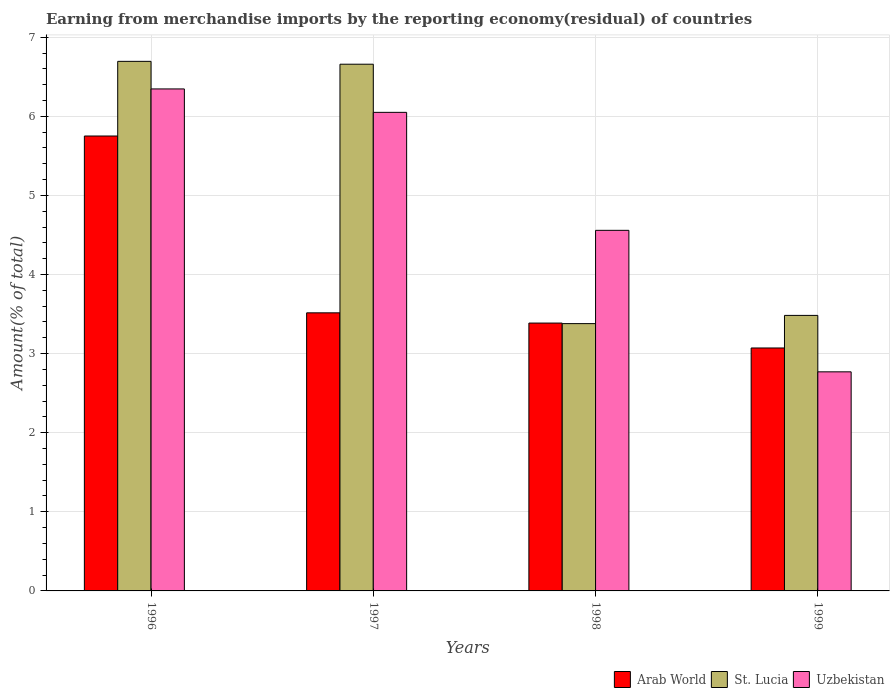How many different coloured bars are there?
Offer a terse response. 3. Are the number of bars per tick equal to the number of legend labels?
Your answer should be very brief. Yes. Are the number of bars on each tick of the X-axis equal?
Your answer should be compact. Yes. How many bars are there on the 3rd tick from the left?
Give a very brief answer. 3. How many bars are there on the 4th tick from the right?
Keep it short and to the point. 3. In how many cases, is the number of bars for a given year not equal to the number of legend labels?
Provide a short and direct response. 0. What is the percentage of amount earned from merchandise imports in St. Lucia in 1997?
Give a very brief answer. 6.66. Across all years, what is the maximum percentage of amount earned from merchandise imports in St. Lucia?
Your answer should be compact. 6.69. Across all years, what is the minimum percentage of amount earned from merchandise imports in St. Lucia?
Offer a terse response. 3.38. In which year was the percentage of amount earned from merchandise imports in Uzbekistan maximum?
Give a very brief answer. 1996. In which year was the percentage of amount earned from merchandise imports in Uzbekistan minimum?
Offer a very short reply. 1999. What is the total percentage of amount earned from merchandise imports in Arab World in the graph?
Your answer should be very brief. 15.72. What is the difference between the percentage of amount earned from merchandise imports in Arab World in 1997 and that in 1999?
Ensure brevity in your answer.  0.44. What is the difference between the percentage of amount earned from merchandise imports in Arab World in 1997 and the percentage of amount earned from merchandise imports in Uzbekistan in 1999?
Give a very brief answer. 0.75. What is the average percentage of amount earned from merchandise imports in Uzbekistan per year?
Provide a short and direct response. 4.93. In the year 1998, what is the difference between the percentage of amount earned from merchandise imports in St. Lucia and percentage of amount earned from merchandise imports in Uzbekistan?
Provide a short and direct response. -1.18. What is the ratio of the percentage of amount earned from merchandise imports in Uzbekistan in 1998 to that in 1999?
Make the answer very short. 1.65. Is the difference between the percentage of amount earned from merchandise imports in St. Lucia in 1998 and 1999 greater than the difference between the percentage of amount earned from merchandise imports in Uzbekistan in 1998 and 1999?
Provide a succinct answer. No. What is the difference between the highest and the second highest percentage of amount earned from merchandise imports in Uzbekistan?
Your response must be concise. 0.3. What is the difference between the highest and the lowest percentage of amount earned from merchandise imports in St. Lucia?
Give a very brief answer. 3.32. In how many years, is the percentage of amount earned from merchandise imports in St. Lucia greater than the average percentage of amount earned from merchandise imports in St. Lucia taken over all years?
Your answer should be very brief. 2. What does the 2nd bar from the left in 1996 represents?
Offer a terse response. St. Lucia. What does the 1st bar from the right in 1996 represents?
Keep it short and to the point. Uzbekistan. What is the difference between two consecutive major ticks on the Y-axis?
Make the answer very short. 1. Does the graph contain any zero values?
Give a very brief answer. No. How many legend labels are there?
Offer a very short reply. 3. How are the legend labels stacked?
Keep it short and to the point. Horizontal. What is the title of the graph?
Make the answer very short. Earning from merchandise imports by the reporting economy(residual) of countries. What is the label or title of the Y-axis?
Offer a terse response. Amount(% of total). What is the Amount(% of total) in Arab World in 1996?
Your answer should be compact. 5.75. What is the Amount(% of total) of St. Lucia in 1996?
Provide a succinct answer. 6.69. What is the Amount(% of total) in Uzbekistan in 1996?
Ensure brevity in your answer.  6.35. What is the Amount(% of total) of Arab World in 1997?
Keep it short and to the point. 3.52. What is the Amount(% of total) in St. Lucia in 1997?
Provide a short and direct response. 6.66. What is the Amount(% of total) of Uzbekistan in 1997?
Provide a short and direct response. 6.05. What is the Amount(% of total) in Arab World in 1998?
Provide a succinct answer. 3.39. What is the Amount(% of total) in St. Lucia in 1998?
Offer a very short reply. 3.38. What is the Amount(% of total) in Uzbekistan in 1998?
Give a very brief answer. 4.56. What is the Amount(% of total) in Arab World in 1999?
Keep it short and to the point. 3.07. What is the Amount(% of total) of St. Lucia in 1999?
Your answer should be very brief. 3.48. What is the Amount(% of total) in Uzbekistan in 1999?
Offer a terse response. 2.77. Across all years, what is the maximum Amount(% of total) of Arab World?
Your answer should be very brief. 5.75. Across all years, what is the maximum Amount(% of total) in St. Lucia?
Your response must be concise. 6.69. Across all years, what is the maximum Amount(% of total) in Uzbekistan?
Your answer should be compact. 6.35. Across all years, what is the minimum Amount(% of total) in Arab World?
Your answer should be very brief. 3.07. Across all years, what is the minimum Amount(% of total) in St. Lucia?
Your answer should be compact. 3.38. Across all years, what is the minimum Amount(% of total) in Uzbekistan?
Offer a terse response. 2.77. What is the total Amount(% of total) of Arab World in the graph?
Provide a succinct answer. 15.72. What is the total Amount(% of total) in St. Lucia in the graph?
Offer a very short reply. 20.21. What is the total Amount(% of total) of Uzbekistan in the graph?
Offer a terse response. 19.72. What is the difference between the Amount(% of total) in Arab World in 1996 and that in 1997?
Your answer should be compact. 2.24. What is the difference between the Amount(% of total) in St. Lucia in 1996 and that in 1997?
Give a very brief answer. 0.04. What is the difference between the Amount(% of total) in Uzbekistan in 1996 and that in 1997?
Your answer should be compact. 0.3. What is the difference between the Amount(% of total) in Arab World in 1996 and that in 1998?
Offer a terse response. 2.36. What is the difference between the Amount(% of total) of St. Lucia in 1996 and that in 1998?
Offer a terse response. 3.32. What is the difference between the Amount(% of total) in Uzbekistan in 1996 and that in 1998?
Provide a succinct answer. 1.79. What is the difference between the Amount(% of total) of Arab World in 1996 and that in 1999?
Your answer should be very brief. 2.68. What is the difference between the Amount(% of total) in St. Lucia in 1996 and that in 1999?
Offer a terse response. 3.21. What is the difference between the Amount(% of total) in Uzbekistan in 1996 and that in 1999?
Make the answer very short. 3.58. What is the difference between the Amount(% of total) in Arab World in 1997 and that in 1998?
Your response must be concise. 0.13. What is the difference between the Amount(% of total) in St. Lucia in 1997 and that in 1998?
Your answer should be very brief. 3.28. What is the difference between the Amount(% of total) of Uzbekistan in 1997 and that in 1998?
Offer a terse response. 1.49. What is the difference between the Amount(% of total) in Arab World in 1997 and that in 1999?
Give a very brief answer. 0.44. What is the difference between the Amount(% of total) of St. Lucia in 1997 and that in 1999?
Your answer should be compact. 3.18. What is the difference between the Amount(% of total) in Uzbekistan in 1997 and that in 1999?
Provide a succinct answer. 3.28. What is the difference between the Amount(% of total) of Arab World in 1998 and that in 1999?
Keep it short and to the point. 0.32. What is the difference between the Amount(% of total) in St. Lucia in 1998 and that in 1999?
Offer a terse response. -0.1. What is the difference between the Amount(% of total) in Uzbekistan in 1998 and that in 1999?
Keep it short and to the point. 1.79. What is the difference between the Amount(% of total) in Arab World in 1996 and the Amount(% of total) in St. Lucia in 1997?
Your answer should be compact. -0.91. What is the difference between the Amount(% of total) in Arab World in 1996 and the Amount(% of total) in Uzbekistan in 1997?
Offer a terse response. -0.3. What is the difference between the Amount(% of total) of St. Lucia in 1996 and the Amount(% of total) of Uzbekistan in 1997?
Your answer should be very brief. 0.64. What is the difference between the Amount(% of total) in Arab World in 1996 and the Amount(% of total) in St. Lucia in 1998?
Your response must be concise. 2.37. What is the difference between the Amount(% of total) in Arab World in 1996 and the Amount(% of total) in Uzbekistan in 1998?
Offer a very short reply. 1.19. What is the difference between the Amount(% of total) of St. Lucia in 1996 and the Amount(% of total) of Uzbekistan in 1998?
Make the answer very short. 2.14. What is the difference between the Amount(% of total) of Arab World in 1996 and the Amount(% of total) of St. Lucia in 1999?
Keep it short and to the point. 2.27. What is the difference between the Amount(% of total) in Arab World in 1996 and the Amount(% of total) in Uzbekistan in 1999?
Ensure brevity in your answer.  2.98. What is the difference between the Amount(% of total) of St. Lucia in 1996 and the Amount(% of total) of Uzbekistan in 1999?
Keep it short and to the point. 3.92. What is the difference between the Amount(% of total) in Arab World in 1997 and the Amount(% of total) in St. Lucia in 1998?
Ensure brevity in your answer.  0.14. What is the difference between the Amount(% of total) of Arab World in 1997 and the Amount(% of total) of Uzbekistan in 1998?
Your answer should be very brief. -1.04. What is the difference between the Amount(% of total) of Arab World in 1997 and the Amount(% of total) of St. Lucia in 1999?
Ensure brevity in your answer.  0.03. What is the difference between the Amount(% of total) in Arab World in 1997 and the Amount(% of total) in Uzbekistan in 1999?
Offer a terse response. 0.75. What is the difference between the Amount(% of total) of St. Lucia in 1997 and the Amount(% of total) of Uzbekistan in 1999?
Provide a short and direct response. 3.89. What is the difference between the Amount(% of total) in Arab World in 1998 and the Amount(% of total) in St. Lucia in 1999?
Offer a terse response. -0.1. What is the difference between the Amount(% of total) in Arab World in 1998 and the Amount(% of total) in Uzbekistan in 1999?
Offer a very short reply. 0.62. What is the difference between the Amount(% of total) in St. Lucia in 1998 and the Amount(% of total) in Uzbekistan in 1999?
Keep it short and to the point. 0.61. What is the average Amount(% of total) in Arab World per year?
Provide a succinct answer. 3.93. What is the average Amount(% of total) in St. Lucia per year?
Your answer should be compact. 5.05. What is the average Amount(% of total) in Uzbekistan per year?
Ensure brevity in your answer.  4.93. In the year 1996, what is the difference between the Amount(% of total) in Arab World and Amount(% of total) in St. Lucia?
Ensure brevity in your answer.  -0.94. In the year 1996, what is the difference between the Amount(% of total) in Arab World and Amount(% of total) in Uzbekistan?
Give a very brief answer. -0.6. In the year 1996, what is the difference between the Amount(% of total) in St. Lucia and Amount(% of total) in Uzbekistan?
Keep it short and to the point. 0.35. In the year 1997, what is the difference between the Amount(% of total) of Arab World and Amount(% of total) of St. Lucia?
Offer a very short reply. -3.14. In the year 1997, what is the difference between the Amount(% of total) in Arab World and Amount(% of total) in Uzbekistan?
Provide a succinct answer. -2.53. In the year 1997, what is the difference between the Amount(% of total) in St. Lucia and Amount(% of total) in Uzbekistan?
Give a very brief answer. 0.61. In the year 1998, what is the difference between the Amount(% of total) of Arab World and Amount(% of total) of St. Lucia?
Your answer should be very brief. 0.01. In the year 1998, what is the difference between the Amount(% of total) of Arab World and Amount(% of total) of Uzbekistan?
Keep it short and to the point. -1.17. In the year 1998, what is the difference between the Amount(% of total) of St. Lucia and Amount(% of total) of Uzbekistan?
Your response must be concise. -1.18. In the year 1999, what is the difference between the Amount(% of total) of Arab World and Amount(% of total) of St. Lucia?
Your answer should be compact. -0.41. In the year 1999, what is the difference between the Amount(% of total) of Arab World and Amount(% of total) of Uzbekistan?
Your response must be concise. 0.3. In the year 1999, what is the difference between the Amount(% of total) in St. Lucia and Amount(% of total) in Uzbekistan?
Make the answer very short. 0.71. What is the ratio of the Amount(% of total) of Arab World in 1996 to that in 1997?
Ensure brevity in your answer.  1.64. What is the ratio of the Amount(% of total) in St. Lucia in 1996 to that in 1997?
Your answer should be very brief. 1.01. What is the ratio of the Amount(% of total) of Uzbekistan in 1996 to that in 1997?
Offer a terse response. 1.05. What is the ratio of the Amount(% of total) in Arab World in 1996 to that in 1998?
Provide a short and direct response. 1.7. What is the ratio of the Amount(% of total) in St. Lucia in 1996 to that in 1998?
Your answer should be very brief. 1.98. What is the ratio of the Amount(% of total) of Uzbekistan in 1996 to that in 1998?
Make the answer very short. 1.39. What is the ratio of the Amount(% of total) in Arab World in 1996 to that in 1999?
Your response must be concise. 1.87. What is the ratio of the Amount(% of total) of St. Lucia in 1996 to that in 1999?
Provide a short and direct response. 1.92. What is the ratio of the Amount(% of total) in Uzbekistan in 1996 to that in 1999?
Provide a short and direct response. 2.29. What is the ratio of the Amount(% of total) in Arab World in 1997 to that in 1998?
Offer a terse response. 1.04. What is the ratio of the Amount(% of total) in St. Lucia in 1997 to that in 1998?
Your response must be concise. 1.97. What is the ratio of the Amount(% of total) of Uzbekistan in 1997 to that in 1998?
Your answer should be very brief. 1.33. What is the ratio of the Amount(% of total) of Arab World in 1997 to that in 1999?
Your answer should be compact. 1.14. What is the ratio of the Amount(% of total) in St. Lucia in 1997 to that in 1999?
Give a very brief answer. 1.91. What is the ratio of the Amount(% of total) of Uzbekistan in 1997 to that in 1999?
Provide a short and direct response. 2.18. What is the ratio of the Amount(% of total) in Arab World in 1998 to that in 1999?
Provide a short and direct response. 1.1. What is the ratio of the Amount(% of total) in St. Lucia in 1998 to that in 1999?
Your response must be concise. 0.97. What is the ratio of the Amount(% of total) in Uzbekistan in 1998 to that in 1999?
Ensure brevity in your answer.  1.65. What is the difference between the highest and the second highest Amount(% of total) in Arab World?
Provide a short and direct response. 2.24. What is the difference between the highest and the second highest Amount(% of total) of St. Lucia?
Offer a terse response. 0.04. What is the difference between the highest and the second highest Amount(% of total) of Uzbekistan?
Provide a short and direct response. 0.3. What is the difference between the highest and the lowest Amount(% of total) in Arab World?
Your answer should be compact. 2.68. What is the difference between the highest and the lowest Amount(% of total) in St. Lucia?
Keep it short and to the point. 3.32. What is the difference between the highest and the lowest Amount(% of total) of Uzbekistan?
Ensure brevity in your answer.  3.58. 